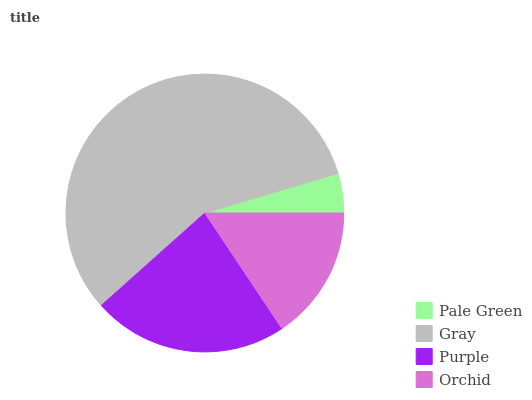Is Pale Green the minimum?
Answer yes or no. Yes. Is Gray the maximum?
Answer yes or no. Yes. Is Purple the minimum?
Answer yes or no. No. Is Purple the maximum?
Answer yes or no. No. Is Gray greater than Purple?
Answer yes or no. Yes. Is Purple less than Gray?
Answer yes or no. Yes. Is Purple greater than Gray?
Answer yes or no. No. Is Gray less than Purple?
Answer yes or no. No. Is Purple the high median?
Answer yes or no. Yes. Is Orchid the low median?
Answer yes or no. Yes. Is Gray the high median?
Answer yes or no. No. Is Pale Green the low median?
Answer yes or no. No. 